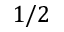Convert formula to latex. <formula><loc_0><loc_0><loc_500><loc_500>1 / 2</formula> 